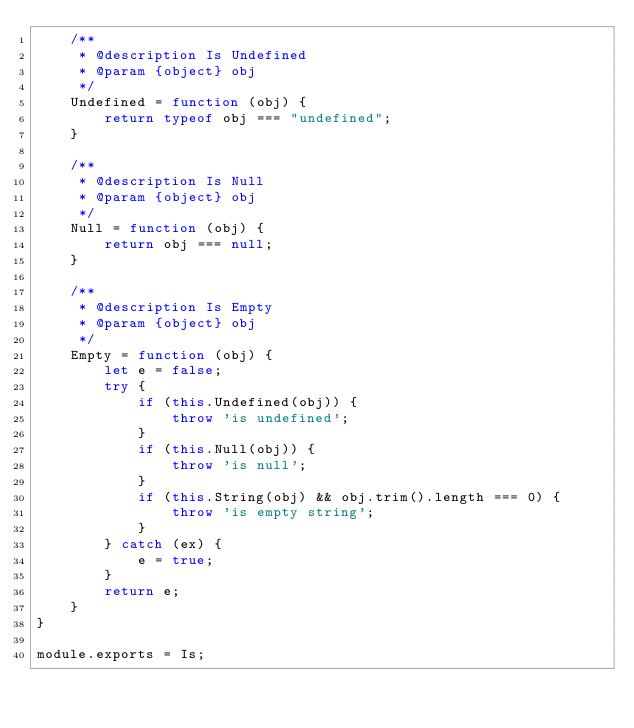Convert code to text. <code><loc_0><loc_0><loc_500><loc_500><_JavaScript_>    /**
     * @description Is Undefined
     * @param {object} obj
     */
    Undefined = function (obj) {
        return typeof obj === "undefined";
    }

    /**
     * @description Is Null
     * @param {object} obj
     */
    Null = function (obj) {
        return obj === null;
    }

    /**
     * @description Is Empty
     * @param {object} obj
     */
    Empty = function (obj) {
        let e = false;
        try {
            if (this.Undefined(obj)) {
                throw 'is undefined';
            }
            if (this.Null(obj)) {
                throw 'is null';
            }
            if (this.String(obj) && obj.trim().length === 0) {
                throw 'is empty string';
            }
        } catch (ex) {
            e = true;
        }
        return e;
    }
}

module.exports = Is;</code> 